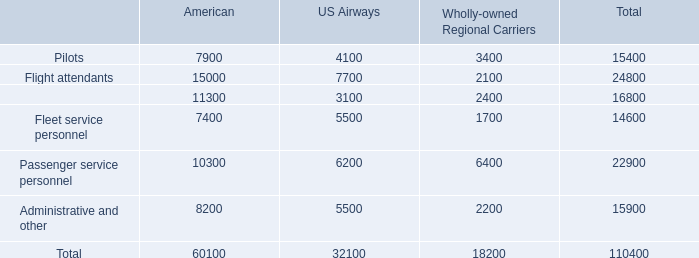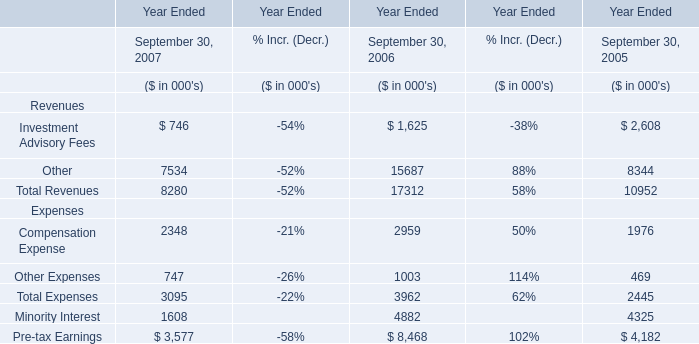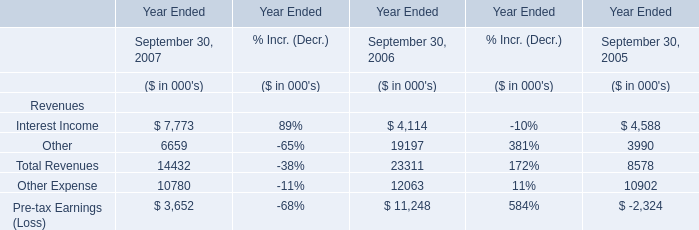As As the chart 1 shows,the Total Revenues in which year ended September 30 ranks first? 
Answer: 2006. 